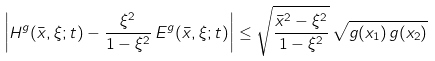<formula> <loc_0><loc_0><loc_500><loc_500>\left | H ^ { g } ( \bar { x } , \xi ; t ) - \frac { \xi ^ { 2 } } { 1 - \xi ^ { 2 } } \, E ^ { g } ( \bar { x } , \xi ; t ) \right | \leq \sqrt { \frac { \bar { x } ^ { 2 } - \xi ^ { 2 } } { 1 - \xi ^ { 2 } } } \, \sqrt { g ( x _ { 1 } ) \, g ( x _ { 2 } ) }</formula> 